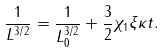Convert formula to latex. <formula><loc_0><loc_0><loc_500><loc_500>\frac { 1 } { L ^ { 3 / 2 } } = \frac { 1 } { L _ { 0 } ^ { 3 / 2 } } + \frac { 3 } { 2 } \chi _ { 1 } \xi \kappa t .</formula> 